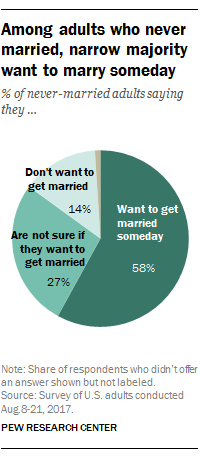Draw attention to some important aspects in this diagram. The pie graph shows the distribution of scores, with a score of 58 representing the highest percentage. The largest pie represented was... 